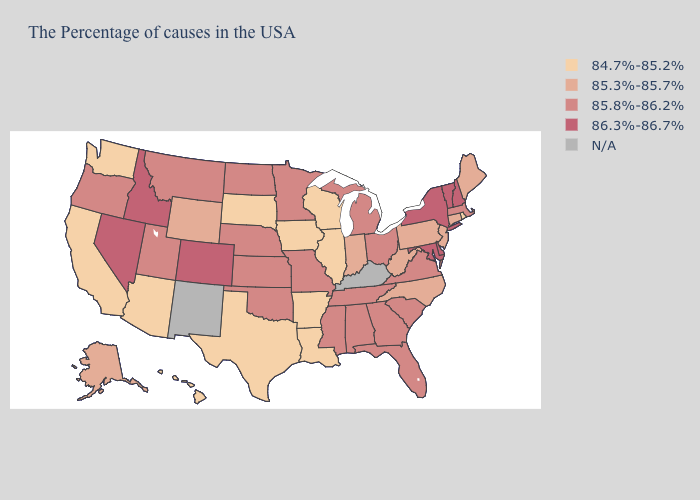How many symbols are there in the legend?
Short answer required. 5. What is the lowest value in the West?
Keep it brief. 84.7%-85.2%. Name the states that have a value in the range 85.8%-86.2%?
Write a very short answer. Massachusetts, Virginia, South Carolina, Ohio, Florida, Georgia, Michigan, Alabama, Tennessee, Mississippi, Missouri, Minnesota, Kansas, Nebraska, Oklahoma, North Dakota, Utah, Montana, Oregon. Name the states that have a value in the range 85.3%-85.7%?
Short answer required. Maine, Connecticut, New Jersey, Pennsylvania, North Carolina, West Virginia, Indiana, Wyoming, Alaska. What is the value of Missouri?
Concise answer only. 85.8%-86.2%. Does the first symbol in the legend represent the smallest category?
Give a very brief answer. Yes. Name the states that have a value in the range 85.8%-86.2%?
Answer briefly. Massachusetts, Virginia, South Carolina, Ohio, Florida, Georgia, Michigan, Alabama, Tennessee, Mississippi, Missouri, Minnesota, Kansas, Nebraska, Oklahoma, North Dakota, Utah, Montana, Oregon. Does Maryland have the lowest value in the USA?
Keep it brief. No. What is the value of Florida?
Be succinct. 85.8%-86.2%. What is the lowest value in states that border Ohio?
Give a very brief answer. 85.3%-85.7%. What is the value of Maine?
Concise answer only. 85.3%-85.7%. What is the value of Florida?
Write a very short answer. 85.8%-86.2%. What is the highest value in the USA?
Be succinct. 86.3%-86.7%. Which states have the lowest value in the USA?
Be succinct. Rhode Island, Wisconsin, Illinois, Louisiana, Arkansas, Iowa, Texas, South Dakota, Arizona, California, Washington, Hawaii. 